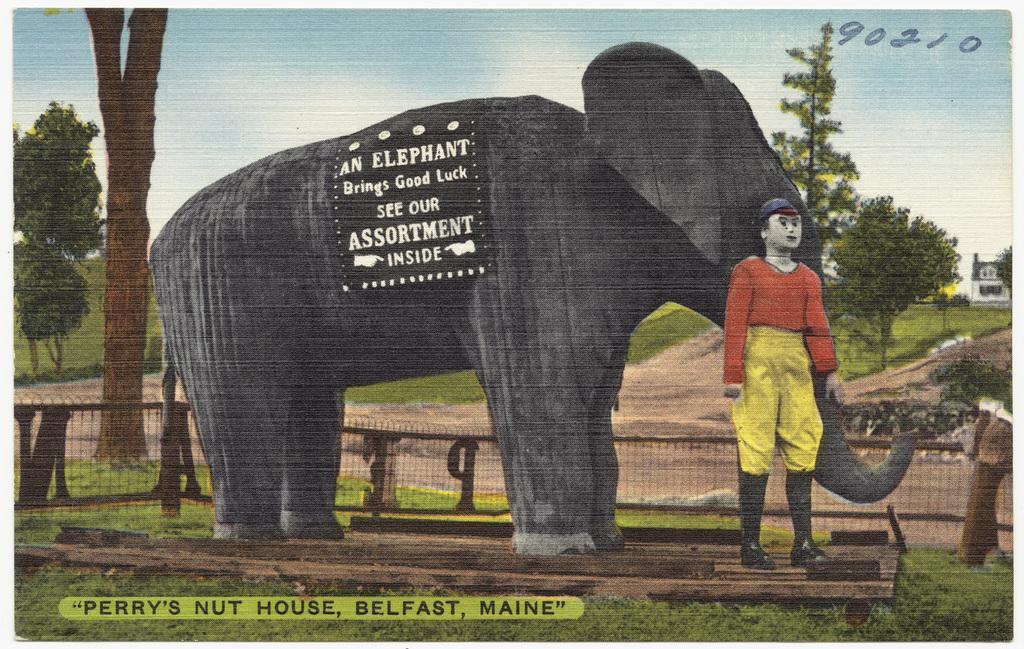Please provide a concise description of this image. This image looks like a poster. In which there is an elephant along with a man. At the bottom, there is a wooden block on the grass. In the background, we can see a fencing along with the trees. At the top, there is sky. 